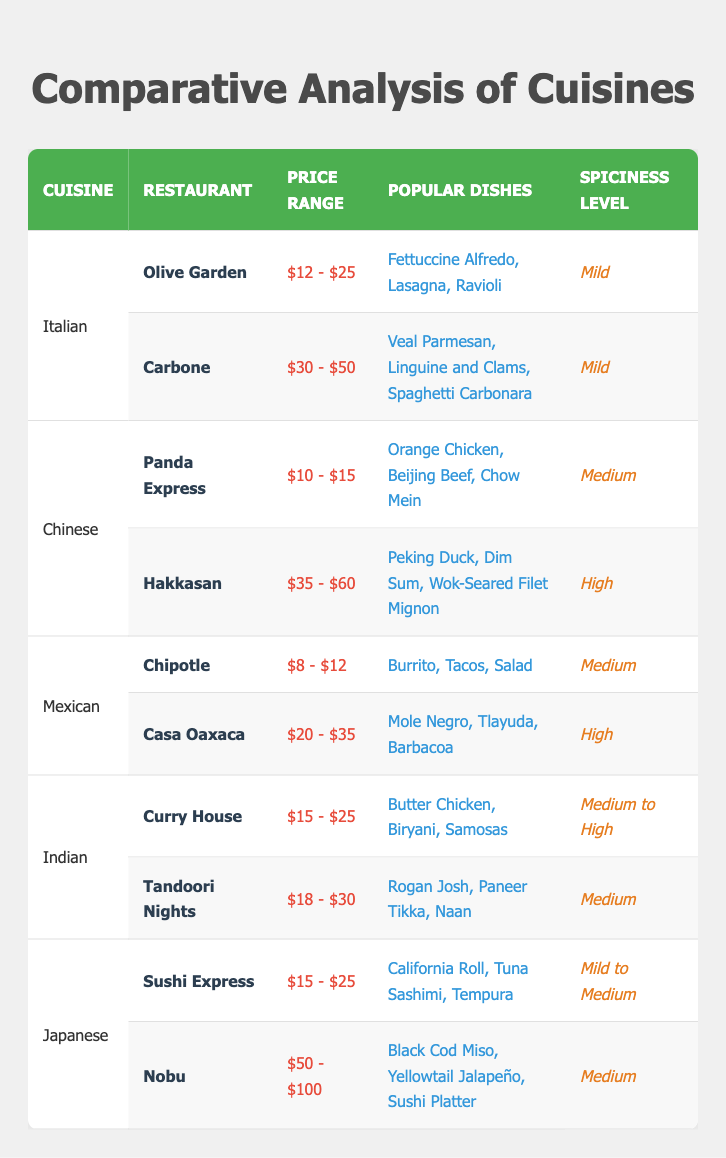What are the popular dishes at Panda Express? The table lists the popular dishes for each restaurant. For Panda Express, the dishes are Orange Chicken, Beijing Beef, and Chow Mein.
Answer: Orange Chicken, Beijing Beef, Chow Mein Which cuisine has the highest average price range? To find the highest average price range, we compare all price ranges listed. Hakkasan has a price range of $35 - $60, and Nobu ranges from $50 - $100. Nobu's price range is the highest.
Answer: Japanese Is the spiciness level for Olive Garden mild? The table specifically states that Olive Garden has a spiciness level of Mild, making this statement true.
Answer: Yes How many restaurants have a spiciness level labeled as high? The table indicates that Hakkasan and Casa Oaxaca have a high spiciness level, giving us a total of 2 restaurants.
Answer: 2 Which cuisine offers a wider range of price for restaurants, Mexican or Italian? Comparing the price ranges: for Mexican, Chipotle ranges from $8 - $12, and Casa Oaxaca from $20 - $35; the range is $8 to $35. For Italian, Olive Garden ranges from $12 - $25 and Carbone from $30 - $50; the range is $12 to $50. Thus, the Italian cuisine has a wider range.
Answer: Italian 